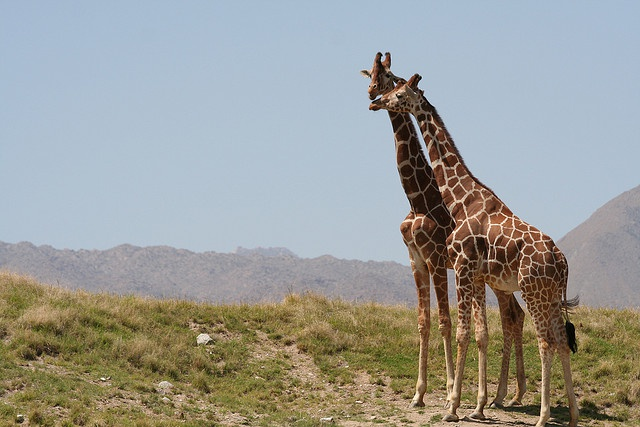Describe the objects in this image and their specific colors. I can see giraffe in darkgray, maroon, black, and gray tones and giraffe in darkgray, black, maroon, and gray tones in this image. 